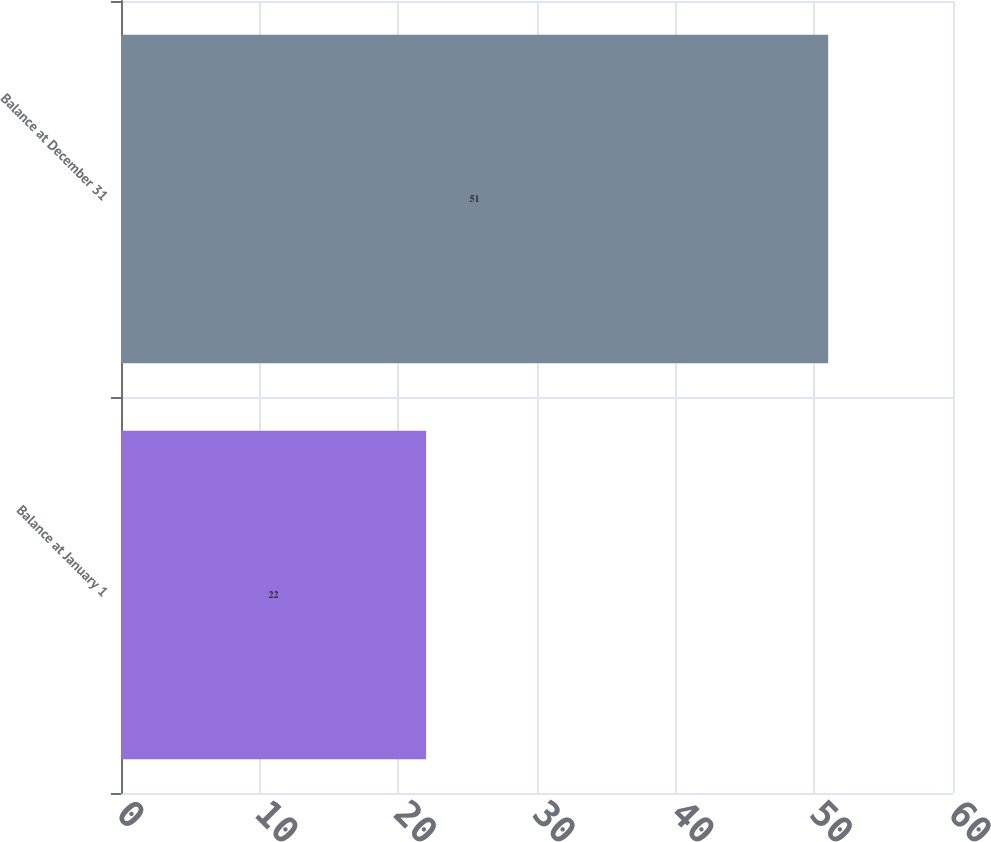Convert chart. <chart><loc_0><loc_0><loc_500><loc_500><bar_chart><fcel>Balance at January 1<fcel>Balance at December 31<nl><fcel>22<fcel>51<nl></chart> 